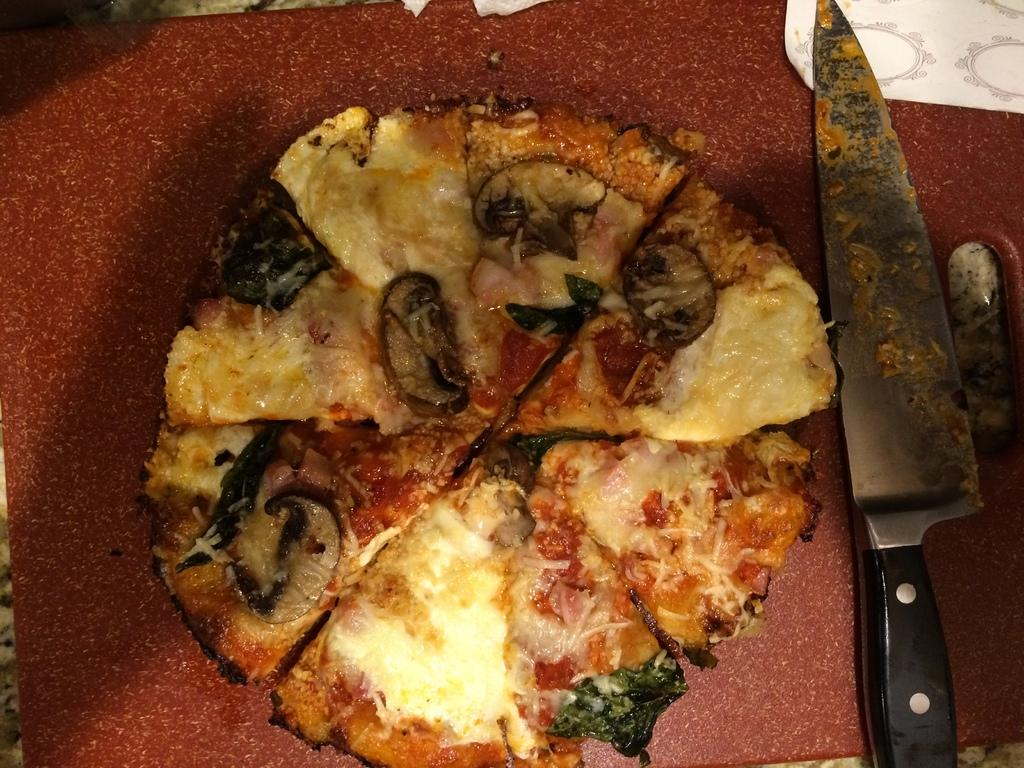What type of food is visible in the image? There is a pizza in the image. What utensil is present in the image? There is a knife in the image. Where are the pizza and knife located? The pizza and knife are on a surface. How does the root of the pizza affect the earthquake in the image? There is no root or earthquake present in the image, so this question cannot be answered. 